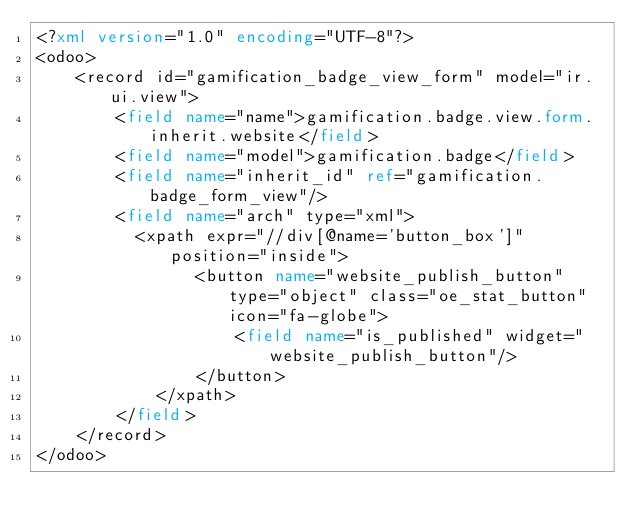Convert code to text. <code><loc_0><loc_0><loc_500><loc_500><_XML_><?xml version="1.0" encoding="UTF-8"?>
<odoo>
    <record id="gamification_badge_view_form" model="ir.ui.view">
        <field name="name">gamification.badge.view.form.inherit.website</field>
        <field name="model">gamification.badge</field>
        <field name="inherit_id" ref="gamification.badge_form_view"/>
        <field name="arch" type="xml">
        	<xpath expr="//div[@name='button_box']" position="inside">
                <button name="website_publish_button" type="object" class="oe_stat_button" icon="fa-globe">
                    <field name="is_published" widget="website_publish_button"/>
                </button>
            </xpath>
        </field>
    </record>
</odoo>
</code> 